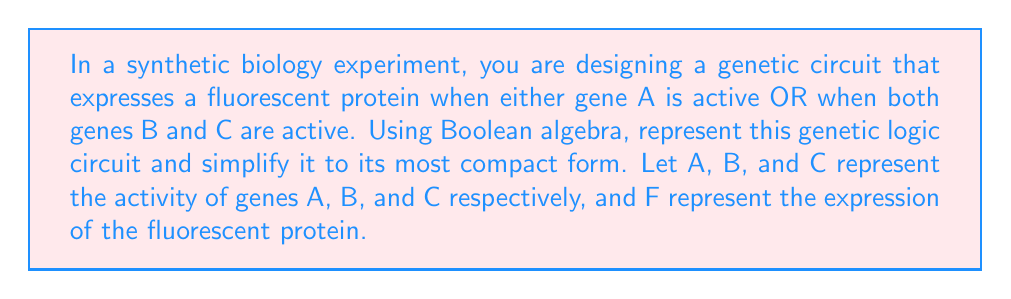Help me with this question. Let's approach this step-by-step:

1) First, we need to represent the genetic logic circuit using Boolean algebra. The circuit expresses the fluorescent protein (F) when:
   - Gene A is active, OR
   - Both genes B and C are active

   We can represent this as:
   $$F = A + (B \cdot C)$$

   Where '+' represents OR, and '·' represents AND.

2) This expression is already in its disjunctive normal form (DNF), which is a standard form in Boolean algebra. However, we can check if it can be simplified further using Boolean algebra laws.

3) Let's apply the distributive law to see if we can simplify:
   $$F = A + (B \cdot C)$$
   $$F = (A + B) \cdot (A + C)$$

4) Expanding this:
   $$F = A \cdot A + A \cdot C + B \cdot A + B \cdot C$$

5) Simplify using the idempotent law (A · A = A):
   $$F = A + A \cdot C + B \cdot A + B \cdot C$$

6) Use the absorption law (A + A · B = A):
   $$F = A + B \cdot C$$

7) We've arrived back at our original expression, which means this is indeed the most simplified form of the Boolean expression for this genetic circuit.

This simplified form is particularly useful in synthetic biology as it represents the minimal set of genetic components needed to achieve the desired logic, potentially reducing the complexity and metabolic burden on the engineered organism.
Answer: $$F = A + (B \cdot C)$$ 